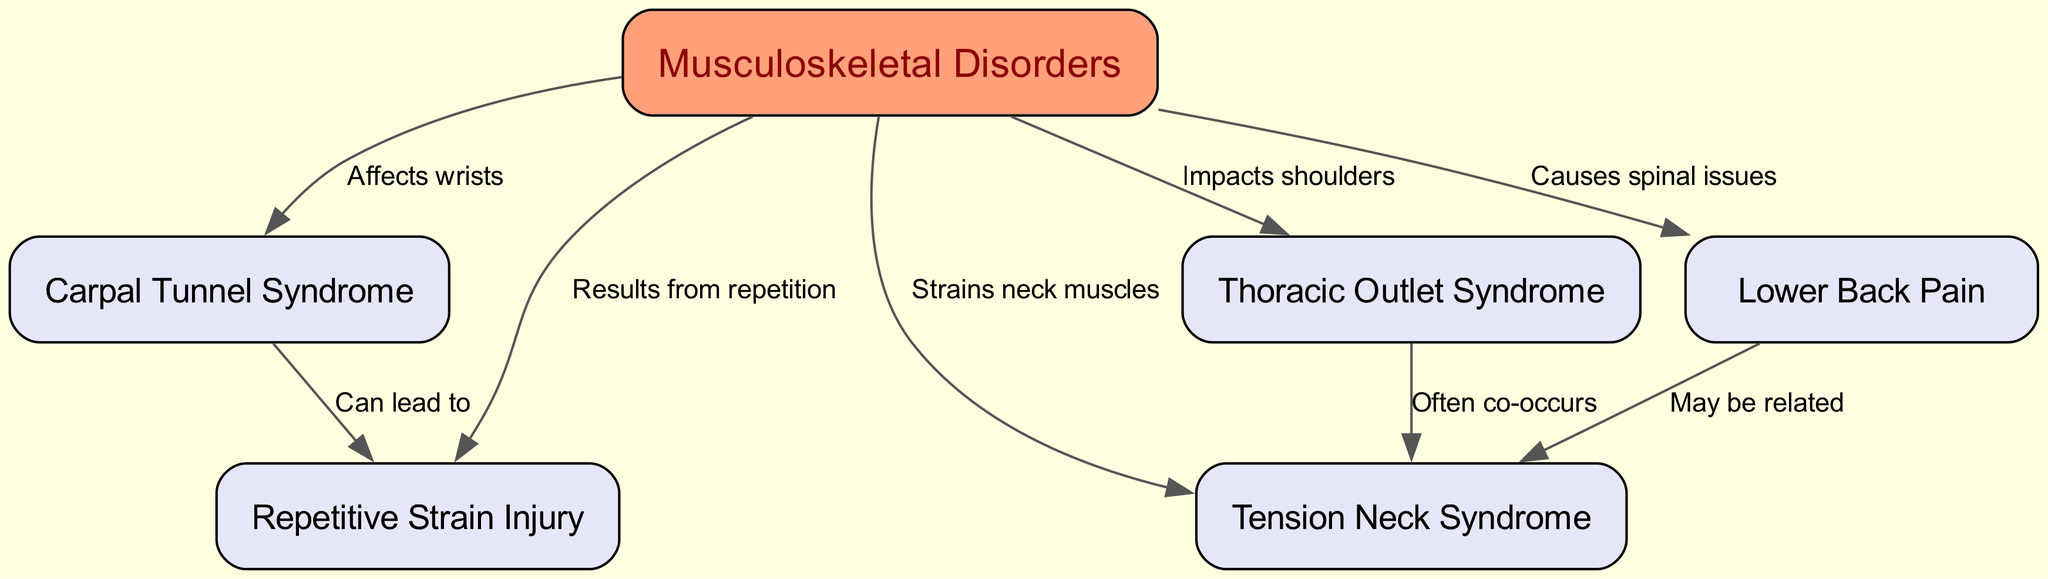What are the types of musculoskeletal disorders listed in the diagram? The diagram includes five types of musculoskeletal disorders: Carpal Tunnel Syndrome, Thoracic Outlet Syndrome, Lower Back Pain, Tension Neck Syndrome, and Repetitive Strain Injury.
Answer: Carpal Tunnel Syndrome, Thoracic Outlet Syndrome, Lower Back Pain, Tension Neck Syndrome, Repetitive Strain Injury How many edges are connected to the node "MSD"? The node "MSD" has four outgoing edges connected to it, linking to Carpal Tunnel Syndrome, Thoracic Outlet Syndrome, Lower Back Pain, and Tension Neck Syndrome.
Answer: 4 What disorder is indicated to affect the wrists? The diagram shows that Carpal Tunnel Syndrome specifically affects the wrists as indicated by the connection from "MSD" to "CTS" labeled "Affects wrists."
Answer: Carpal Tunnel Syndrome Which disorders are mentioned to co-occur according to the diagram? The diagram indicates that Thoracic Outlet Syndrome and Tension Neck Syndrome are often co-occurring, based on the edge connecting them.
Answer: Thoracic Outlet Syndrome, Tension Neck Syndrome What is the relationship between Lower Back Pain and Tension Neck Syndrome? The diagram shows a connection from Lower Back Pain to Tension Neck Syndrome indicating that they "May be related," thus illustrating a relationship between the two disorders.
Answer: May be related How does Carpal Tunnel Syndrome relate to Repetitive Strain Injury? According to the diagram, Carpal Tunnel Syndrome can lead to Repetitive Strain Injury, as shown by the edge connecting "CTS" to "RSI" labeled "Can lead to."
Answer: Can lead to What may cause spinal issues as indicated in the diagram? The diagram explicitly states that Lower Back Pain causes spinal issues, as represented by the edge connecting "MSD" to "LBP" labeled "Causes spinal issues."
Answer: Lower Back Pain What is a common symptom of poor workplace posture shown in this concept map? The diagram highlights multiple musculoskeletal disorders; one common symptom related to poor workplace posture is Tension Neck Syndrome, which strains neck muscles, indicated by the edge from "MSD" to "TNS."
Answer: Tension Neck Syndrome 